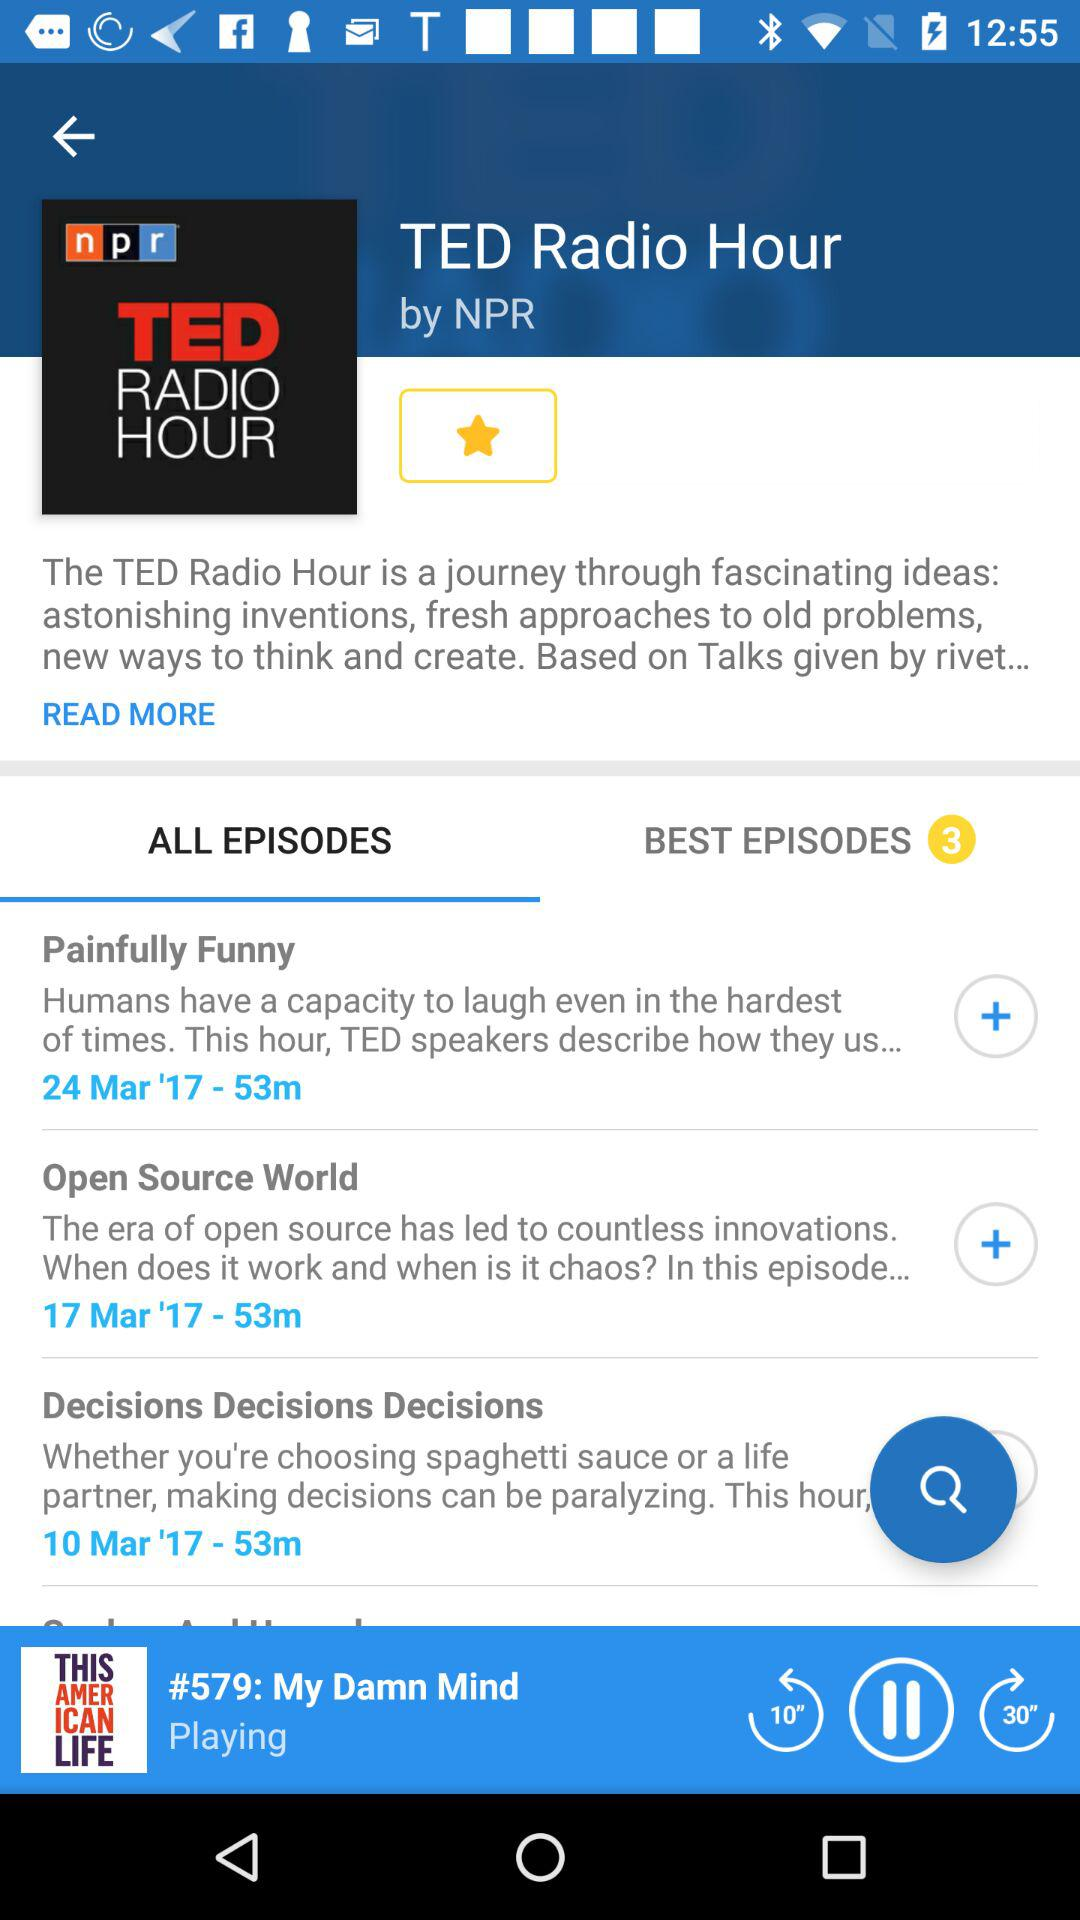What is the date of the "Open Source World" episode? The date of the "Open Source World" episode is March 17, 2017. 